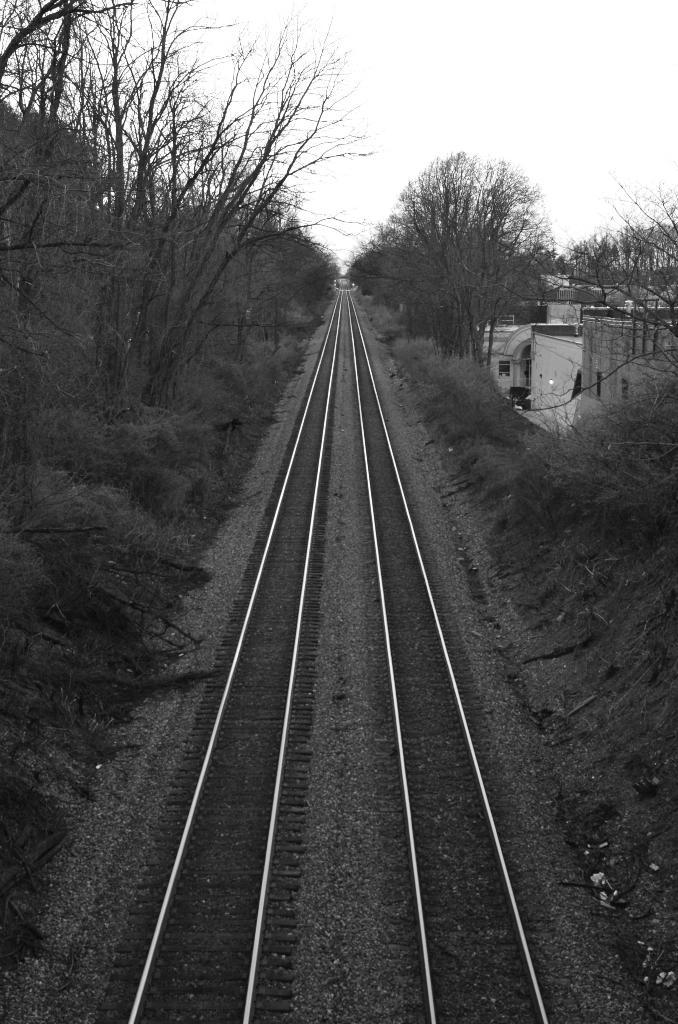What type of transportation infrastructure is present in the image? There are rail tracks in the image. What is the natural environment like in the image? The ground with grass is visible in the image, along with plants and trees. What type of buildings can be seen in the image? There are houses in the image. What part of the natural environment is visible in the image? The sky is visible in the image. What type of collar is visible on the table in the image? There is no table or collar present in the image. What game is being played on the rail tracks in the image? There is no game being played on the rail tracks in the image; they are simply a part of the transportation infrastructure. 